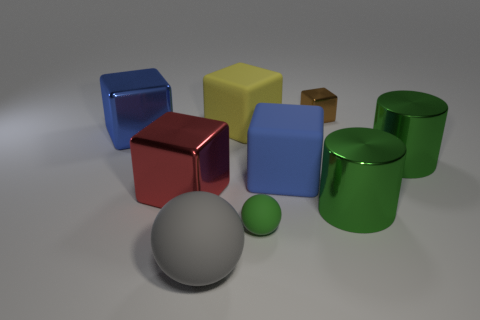Do the tiny green ball that is to the right of the yellow thing and the red thing have the same material?
Your answer should be compact. No. There is a gray matte object that is in front of the small object that is in front of the brown metallic block; how big is it?
Make the answer very short. Large. There is a ball on the left side of the green object that is left of the shiny block right of the green ball; what is its size?
Keep it short and to the point. Large. Is the shape of the big rubber object behind the big blue shiny object the same as the big matte thing to the right of the yellow rubber cube?
Your answer should be very brief. Yes. How many other things are there of the same color as the tiny ball?
Provide a succinct answer. 2. Do the blue matte cube to the right of the blue metal block and the tiny green object have the same size?
Ensure brevity in your answer.  No. Do the blue thing that is in front of the large blue metallic cube and the large thing that is behind the blue metal thing have the same material?
Offer a terse response. Yes. Are there any green objects of the same size as the red thing?
Your response must be concise. Yes. There is a tiny brown thing that is to the right of the big rubber thing that is behind the big cube right of the tiny green object; what is its shape?
Keep it short and to the point. Cube. Is the number of tiny objects left of the small brown block greater than the number of small shiny balls?
Provide a short and direct response. Yes. 